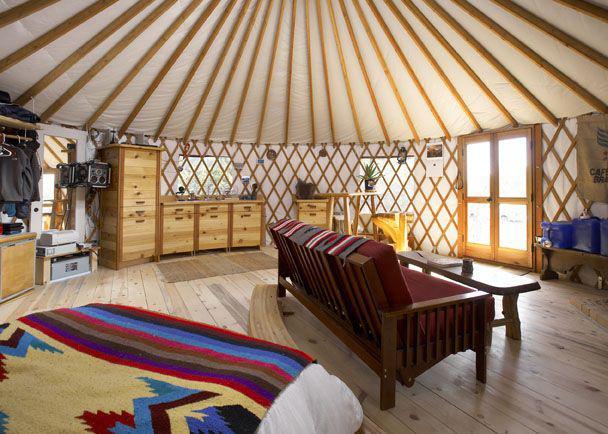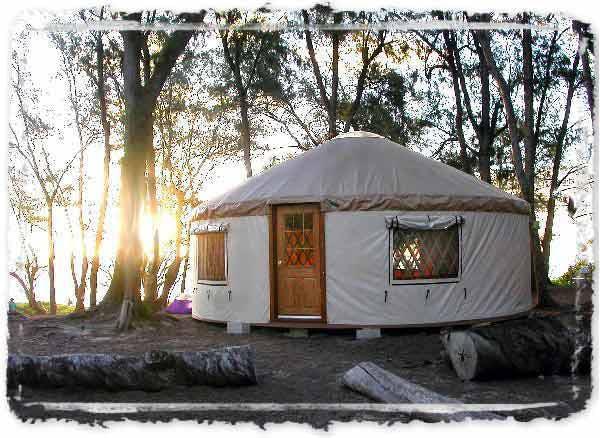The first image is the image on the left, the second image is the image on the right. Analyze the images presented: Is the assertion "There are stairs in the image on the left." valid? Answer yes or no. No. The first image is the image on the left, the second image is the image on the right. Considering the images on both sides, is "A white round house has a forward facing door and at least one window." valid? Answer yes or no. Yes. 